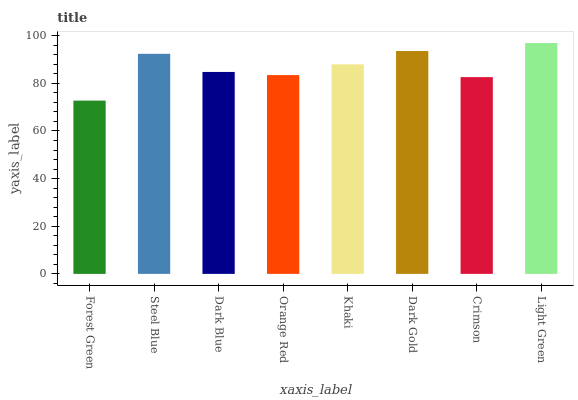Is Steel Blue the minimum?
Answer yes or no. No. Is Steel Blue the maximum?
Answer yes or no. No. Is Steel Blue greater than Forest Green?
Answer yes or no. Yes. Is Forest Green less than Steel Blue?
Answer yes or no. Yes. Is Forest Green greater than Steel Blue?
Answer yes or no. No. Is Steel Blue less than Forest Green?
Answer yes or no. No. Is Khaki the high median?
Answer yes or no. Yes. Is Dark Blue the low median?
Answer yes or no. Yes. Is Dark Gold the high median?
Answer yes or no. No. Is Crimson the low median?
Answer yes or no. No. 